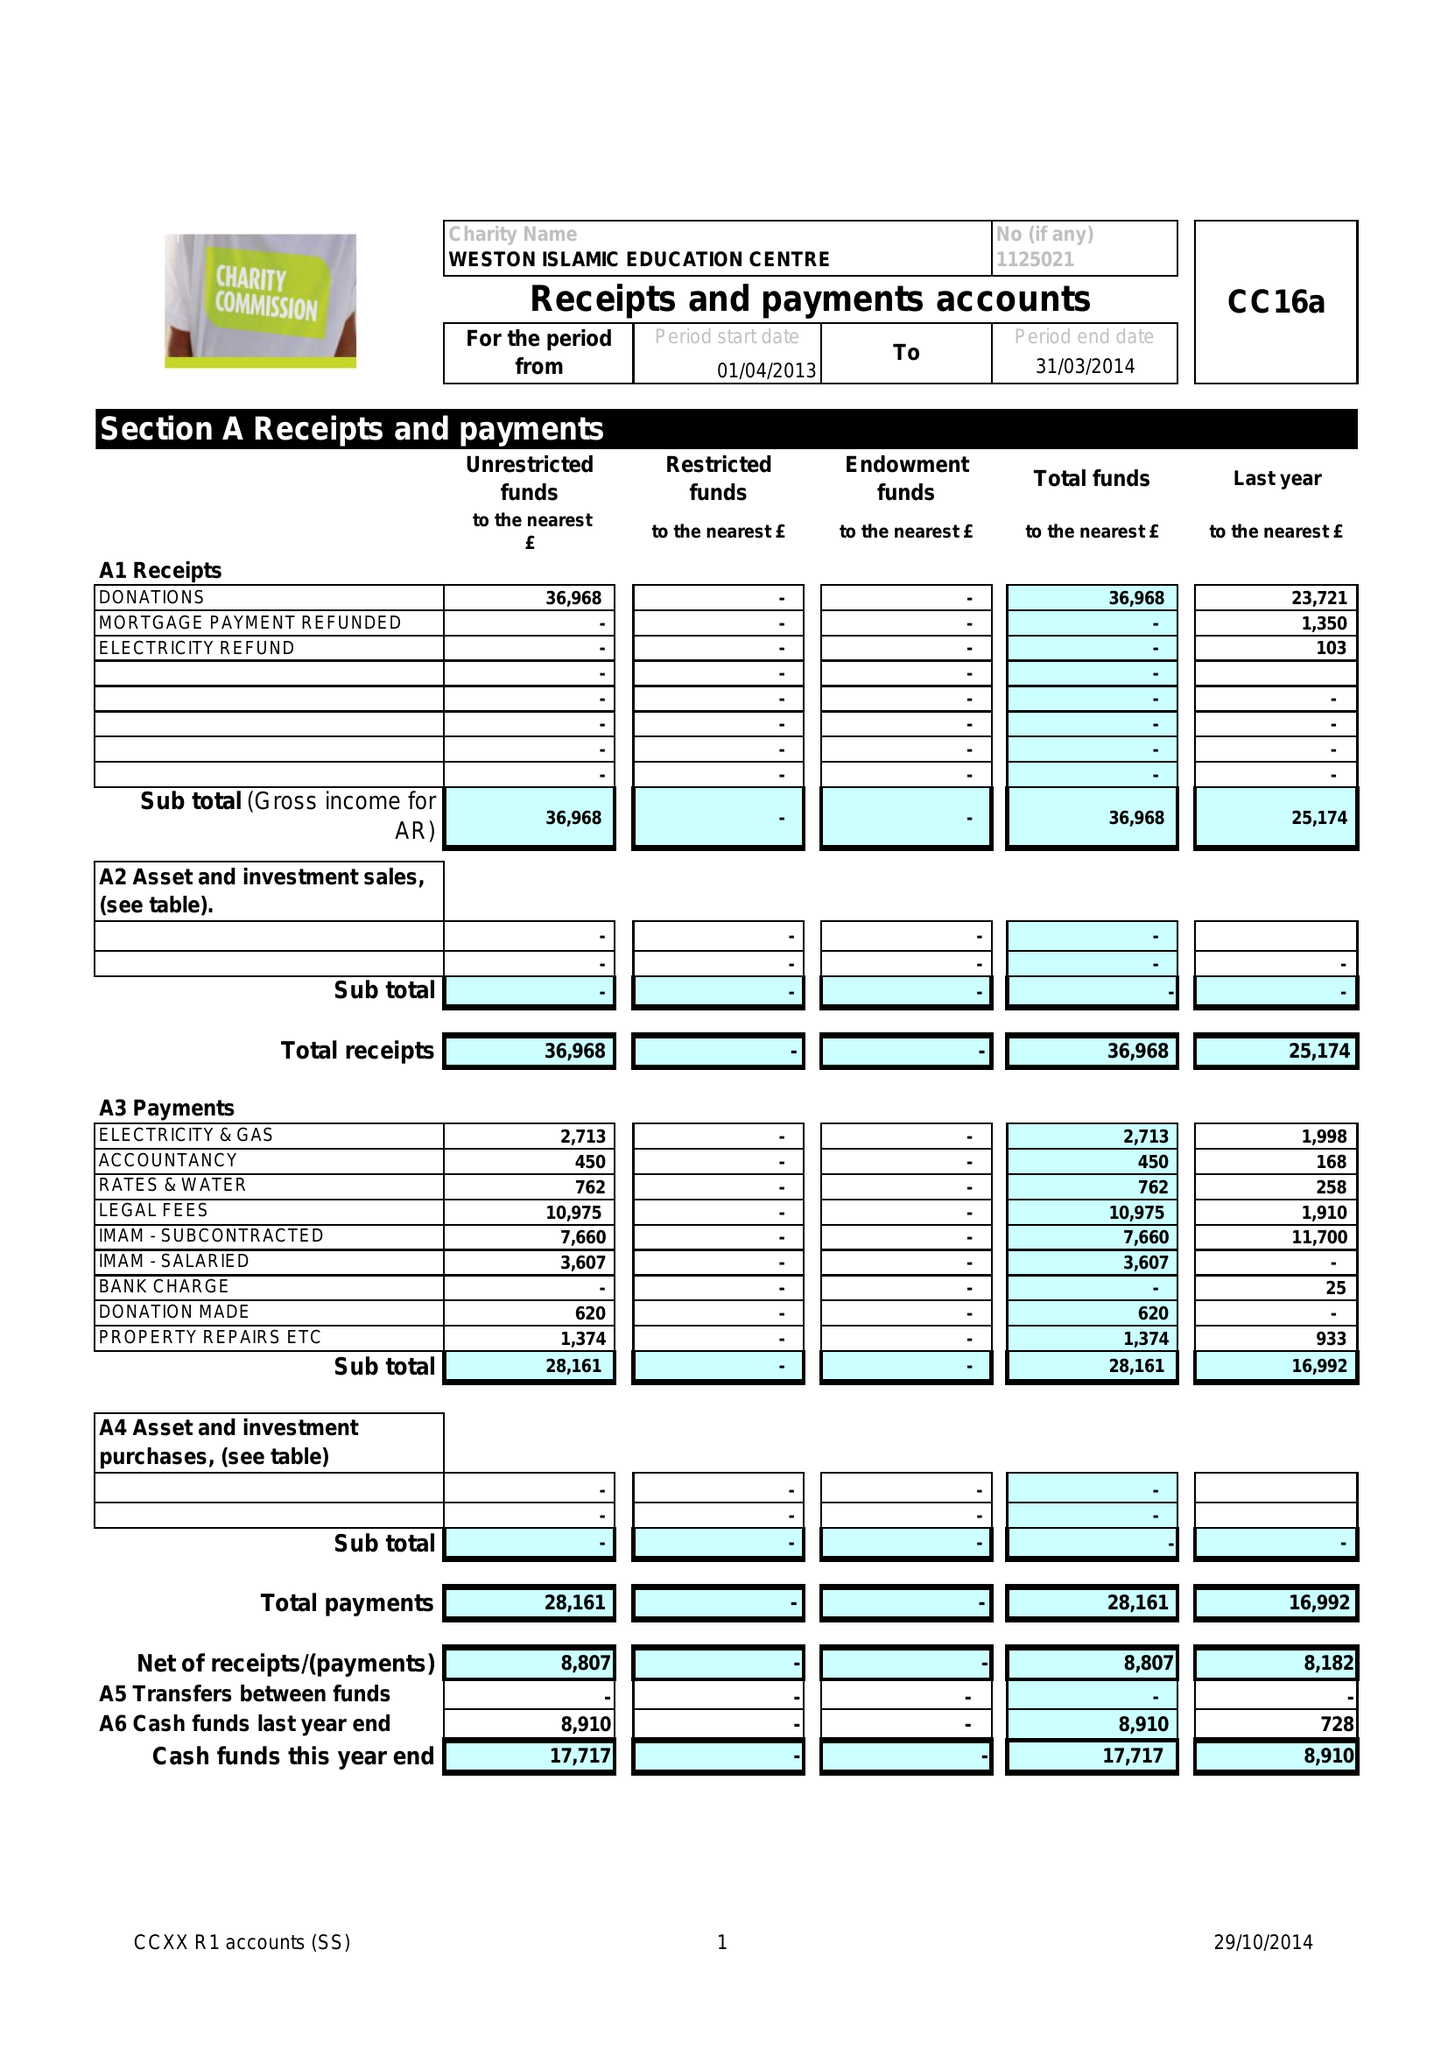What is the value for the income_annually_in_british_pounds?
Answer the question using a single word or phrase. 36968.00 